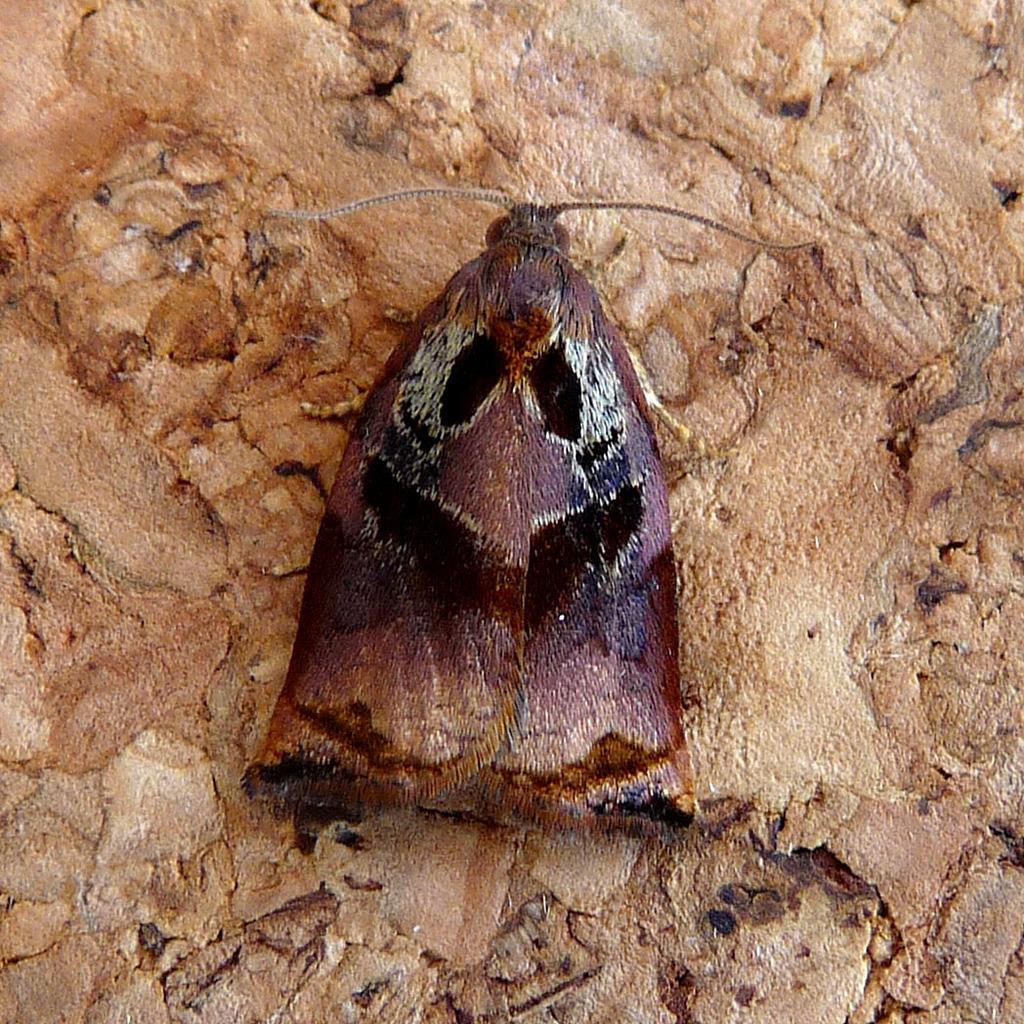Please provide a concise description of this image. In this picture I see the cream color surface, on which there is an insect which is of dark pink, brown and black color. 